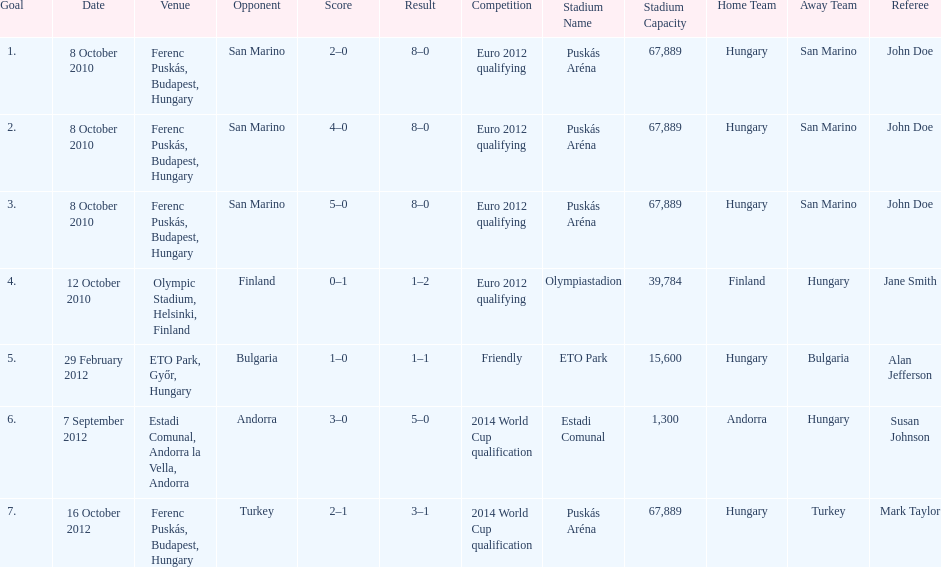What is the total number of international goals ádám szalai has made? 7. 